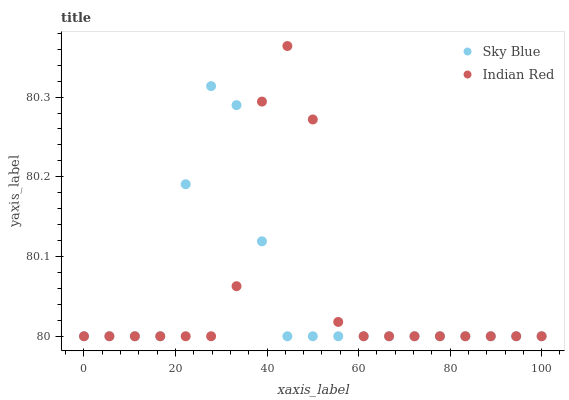Does Sky Blue have the minimum area under the curve?
Answer yes or no. Yes. Does Indian Red have the maximum area under the curve?
Answer yes or no. Yes. Does Indian Red have the minimum area under the curve?
Answer yes or no. No. Is Sky Blue the smoothest?
Answer yes or no. Yes. Is Indian Red the roughest?
Answer yes or no. Yes. Is Indian Red the smoothest?
Answer yes or no. No. Does Sky Blue have the lowest value?
Answer yes or no. Yes. Does Indian Red have the highest value?
Answer yes or no. Yes. Does Sky Blue intersect Indian Red?
Answer yes or no. Yes. Is Sky Blue less than Indian Red?
Answer yes or no. No. Is Sky Blue greater than Indian Red?
Answer yes or no. No. 